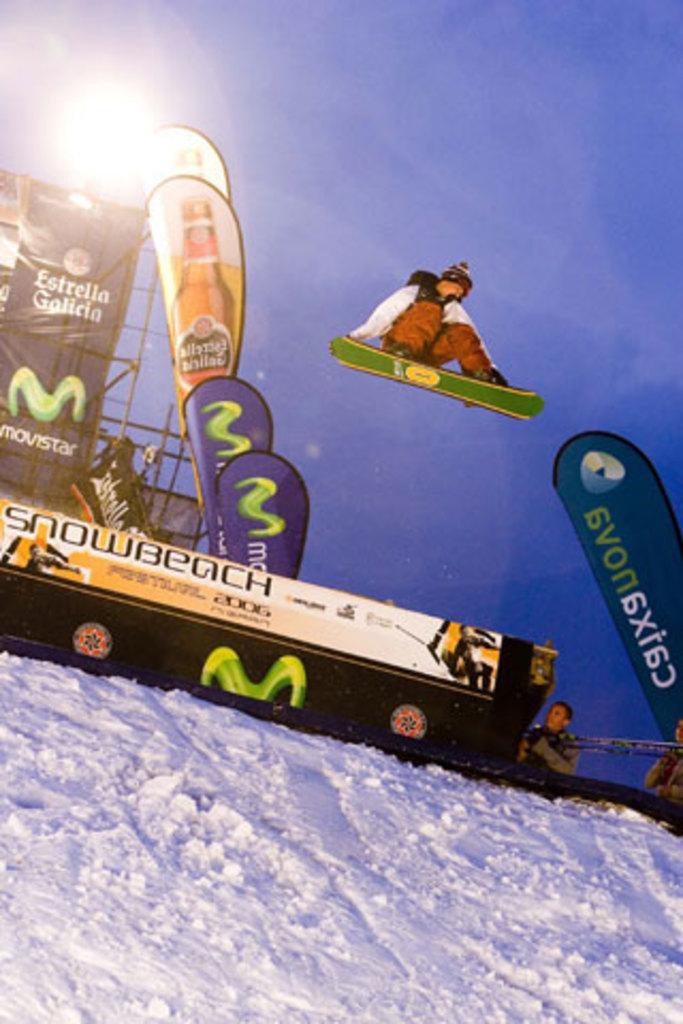How would you summarize this image in a sentence or two? In this image, we can see banner flags. There is a board and banner on the left side of the image. There is a person in the middle of the image jumping with a ski board. There are two person on the right side of the image wearing clothes. There is a sky at the top of the image. 